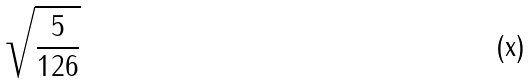Convert formula to latex. <formula><loc_0><loc_0><loc_500><loc_500>\sqrt { \frac { 5 } { 1 2 6 } }</formula> 